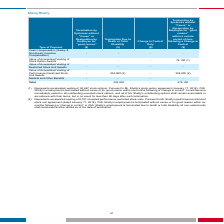From Systemax's financial document, What are Manoj Shetty's respective accelerated vesting of stock options and unvested performance restricted stock units respectively? The document shows two values: 20,687 and 8,107. From the document: "(1) Represents accelerated vesting of 20,687 stock options. Pursuant to Mr. Shetty's stock option agreement (January 17, 2019), if Mr. (2) Represents ..." Also, What is Manoj Shetty's total payment as a result of termination due to death or total disability? According to the financial document, 204,000. The relevant text states: "- 204,000 (2) - 204,000 (2)..." Also, What is Manoj Shetty's total payment due to termination by Systemax without "cause" or resignation for "good reason" within a certain period of time following a change in control? According to the financial document, 278,100. The relevant text states: "Total - 204,000 - 278,100..." Also, can you calculate: What is Manoj Shetty's total accelerated vesting of stock options and unvested performance restricted stock units? Based on the calculation: 20,687 + 8,107 , the result is 28794. This is based on the information: "(1) Represents accelerated vesting of 20,687 stock options. Pursuant to Mr. Shetty's stock option agreement (January 17, 2019), if Mr. (2) Represents accelerated vesting of 8,107 unvested performance ..." The key data points involved are: 20,687, 8,107. Also, can you calculate: What is the value of stock option awards as a percentage of the total payment for termination by Systemax without “Cause” within a certain period of time following a change in control? Based on the calculation: 74,100/278,100 , the result is 26.65 (percentage). This is based on the information: "Total - 204,000 - 278,100 Accelerated Vesting of Stock Option Awards - - - 74,100 (1)..." The key data points involved are: 278,100, 74,100. Also, can you calculate: What is the total payment due to Manoj Shetty from all sources? Based on the calculation: 278,100+ 204,000 , the result is 482100. This is based on the information: "Total - 204,000 - 278,100 Total - 204,000 - 278,100..." The key data points involved are: 204,000, 278,100. 